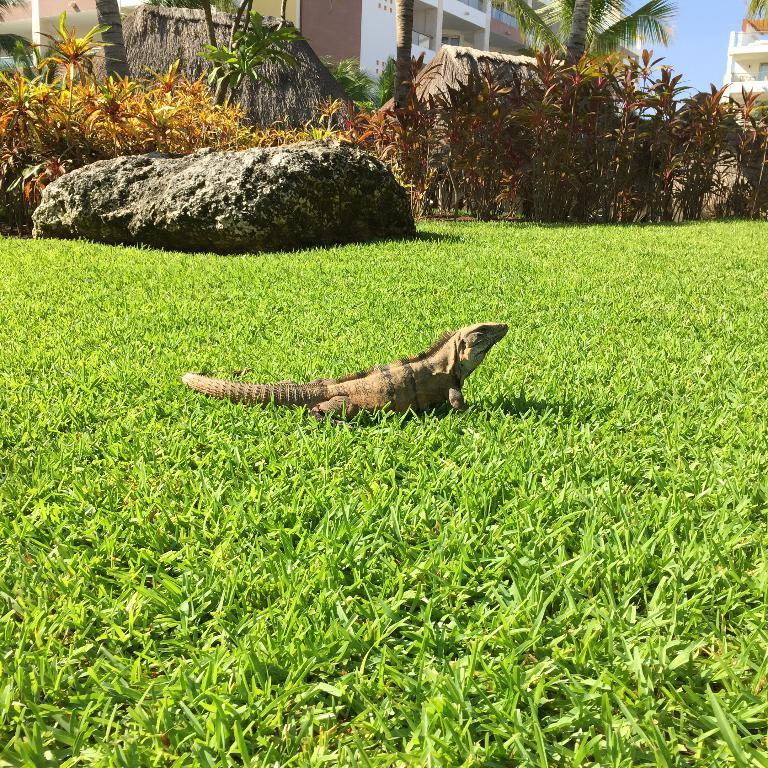What type of animal is in the image? There is a reptile in the image. Where is the reptile located? The reptile is on the grass. What can be seen in the background of the image? There is a rock, plants, trees, and houses in the background of the image. What type of joke does the reptile tell in the image? There is no indication in the image that the reptile is telling a joke, as it is simply located on the grass. 